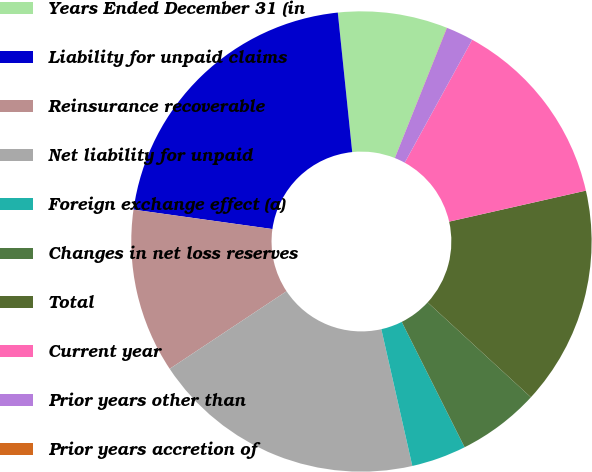<chart> <loc_0><loc_0><loc_500><loc_500><pie_chart><fcel>Years Ended December 31 (in<fcel>Liability for unpaid claims<fcel>Reinsurance recoverable<fcel>Net liability for unpaid<fcel>Foreign exchange effect (a)<fcel>Changes in net loss reserves<fcel>Total<fcel>Current year<fcel>Prior years other than<fcel>Prior years accretion of<nl><fcel>7.69%<fcel>21.15%<fcel>11.54%<fcel>19.22%<fcel>3.85%<fcel>5.77%<fcel>15.38%<fcel>13.46%<fcel>1.93%<fcel>0.01%<nl></chart> 